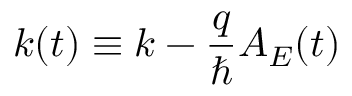Convert formula to latex. <formula><loc_0><loc_0><loc_500><loc_500>k ( t ) \equiv k - \frac { q } { } A _ { E } ( t )</formula> 